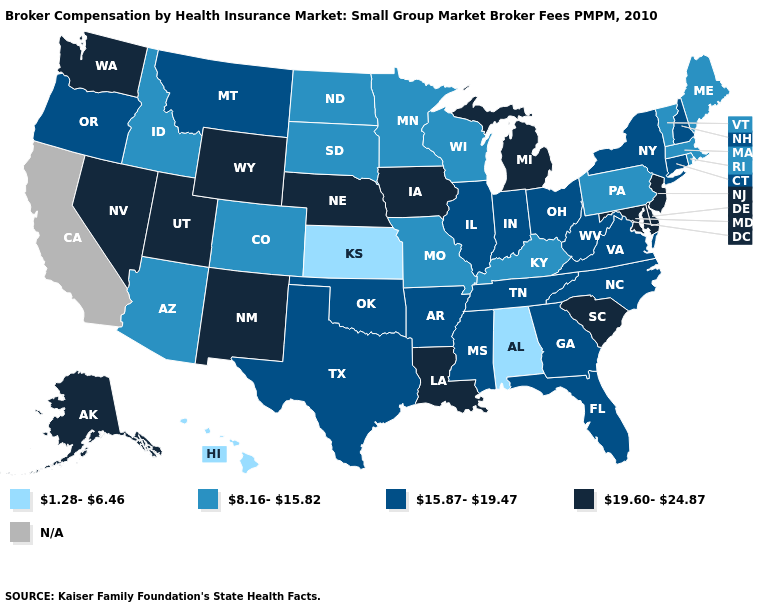Does the first symbol in the legend represent the smallest category?
Give a very brief answer. Yes. Among the states that border Kentucky , does Missouri have the lowest value?
Quick response, please. Yes. What is the lowest value in states that border New Mexico?
Quick response, please. 8.16-15.82. Does New Hampshire have the lowest value in the Northeast?
Give a very brief answer. No. Name the states that have a value in the range N/A?
Keep it brief. California. Name the states that have a value in the range N/A?
Be succinct. California. Which states have the lowest value in the USA?
Keep it brief. Alabama, Hawaii, Kansas. Does Illinois have the lowest value in the USA?
Quick response, please. No. Does Illinois have the highest value in the USA?
Answer briefly. No. Name the states that have a value in the range 1.28-6.46?
Be succinct. Alabama, Hawaii, Kansas. Does the map have missing data?
Short answer required. Yes. Among the states that border New York , does New Jersey have the lowest value?
Write a very short answer. No. What is the highest value in the USA?
Be succinct. 19.60-24.87. What is the highest value in the USA?
Short answer required. 19.60-24.87. 